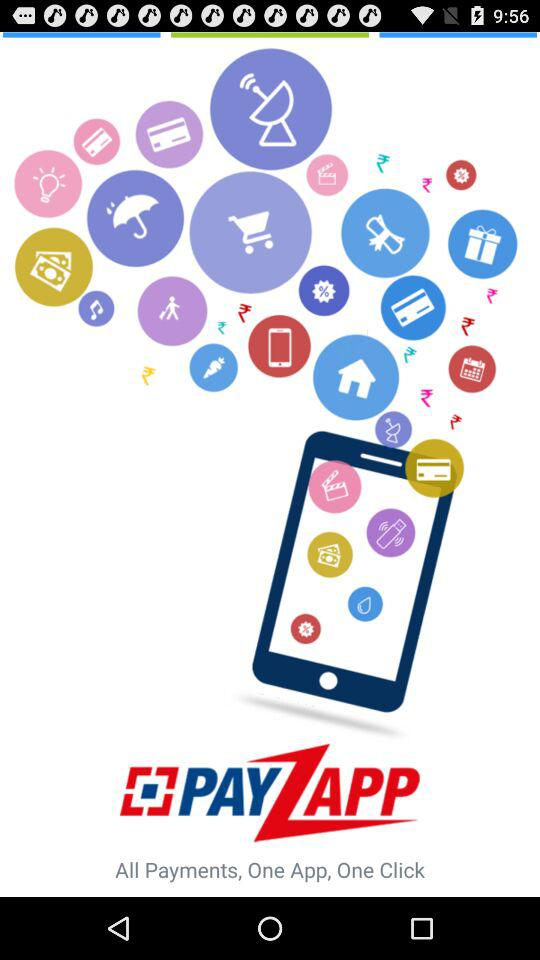What is the name of the application? The name of the application is "PayZapp". 